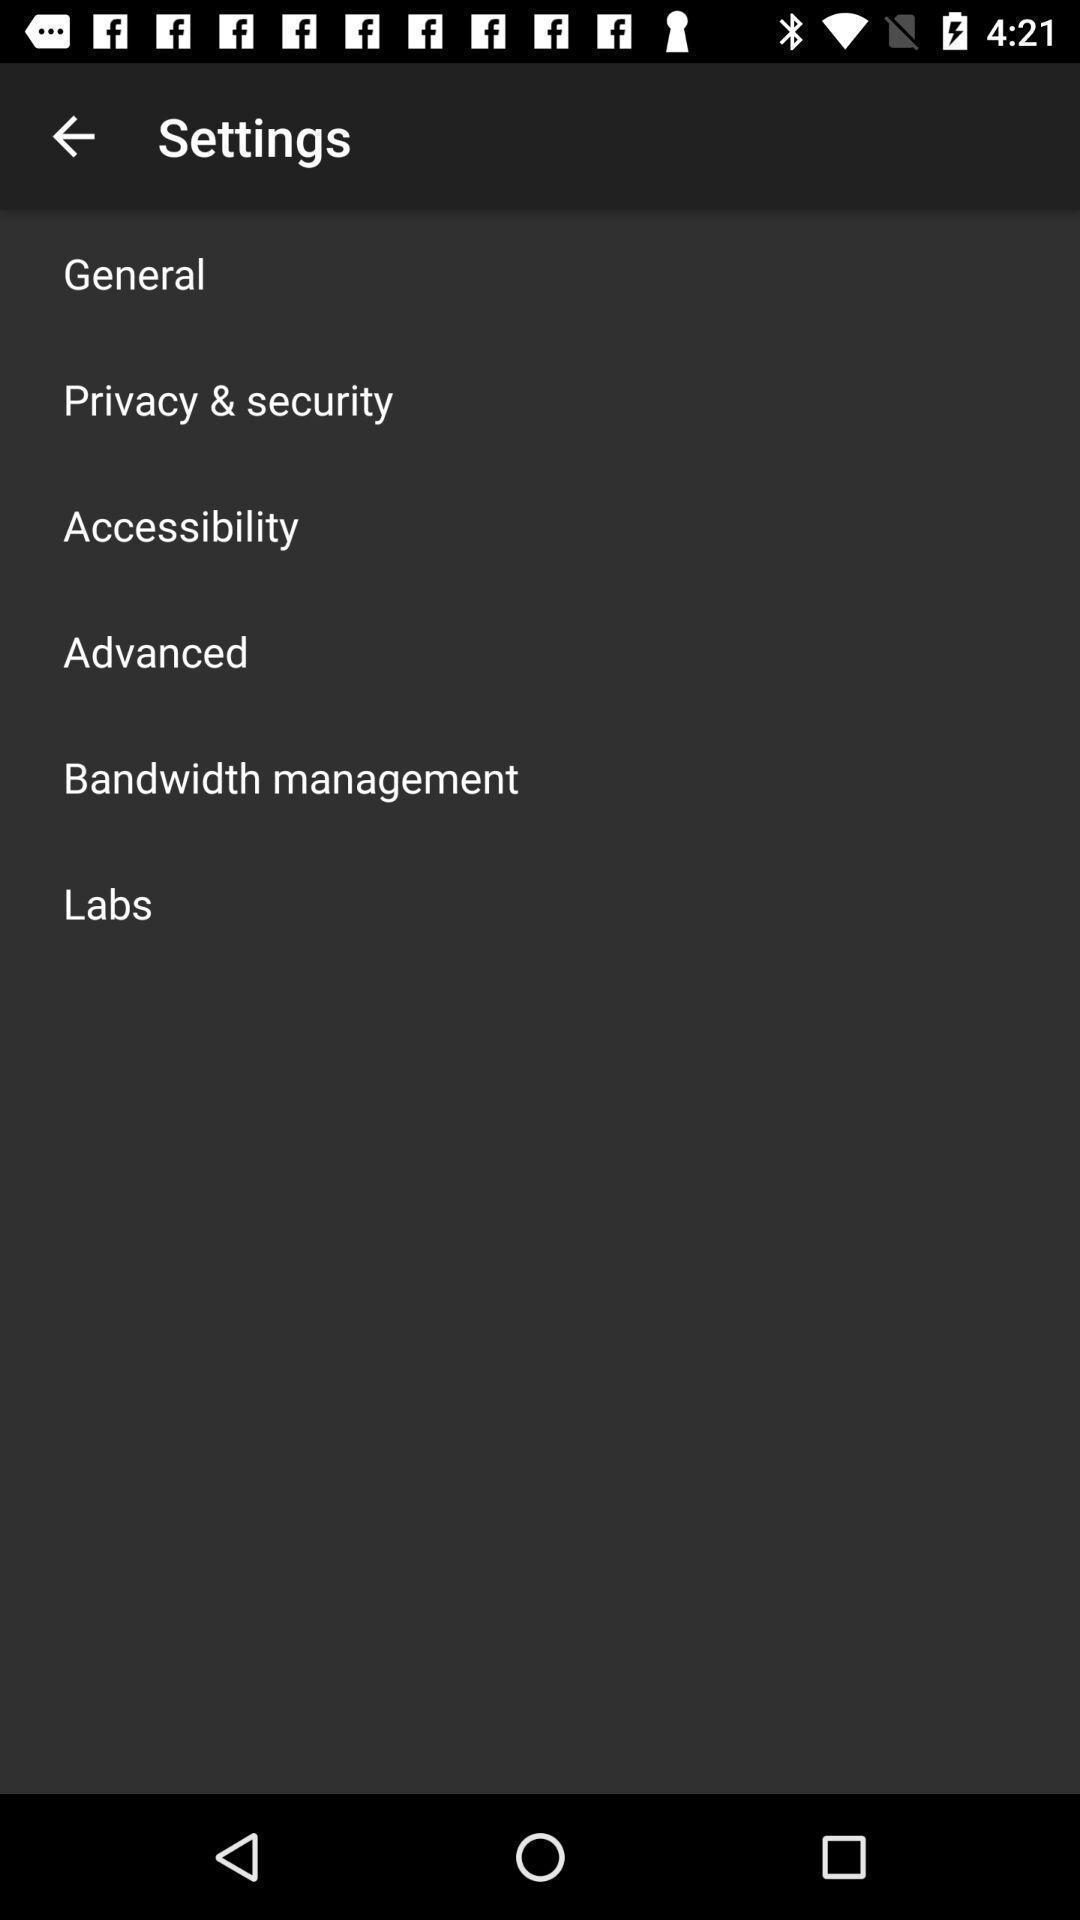Summarize the main components in this picture. Setting page displaying various options. 